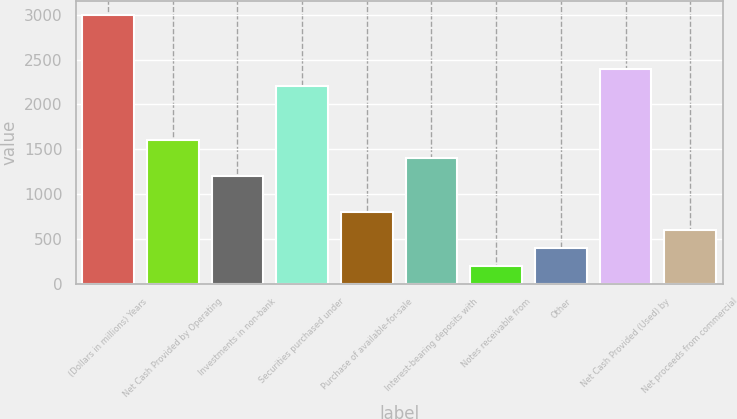Convert chart to OTSL. <chart><loc_0><loc_0><loc_500><loc_500><bar_chart><fcel>(Dollars in millions) Years<fcel>Net Cash Provided by Operating<fcel>Investments in non-bank<fcel>Securities purchased under<fcel>Purchase of available-for-sale<fcel>Interest-bearing deposits with<fcel>Notes receivable from<fcel>Other<fcel>Net Cash Provided (Used) by<fcel>Net proceeds from commercial<nl><fcel>3001.34<fcel>1600.85<fcel>1200.71<fcel>2201.06<fcel>800.57<fcel>1400.78<fcel>200.36<fcel>400.43<fcel>2401.13<fcel>600.5<nl></chart> 